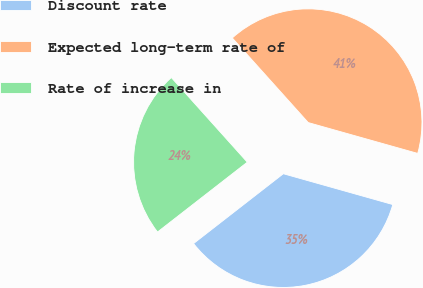<chart> <loc_0><loc_0><loc_500><loc_500><pie_chart><fcel>Discount rate<fcel>Expected long-term rate of<fcel>Rate of increase in<nl><fcel>35.11%<fcel>41.01%<fcel>23.88%<nl></chart> 